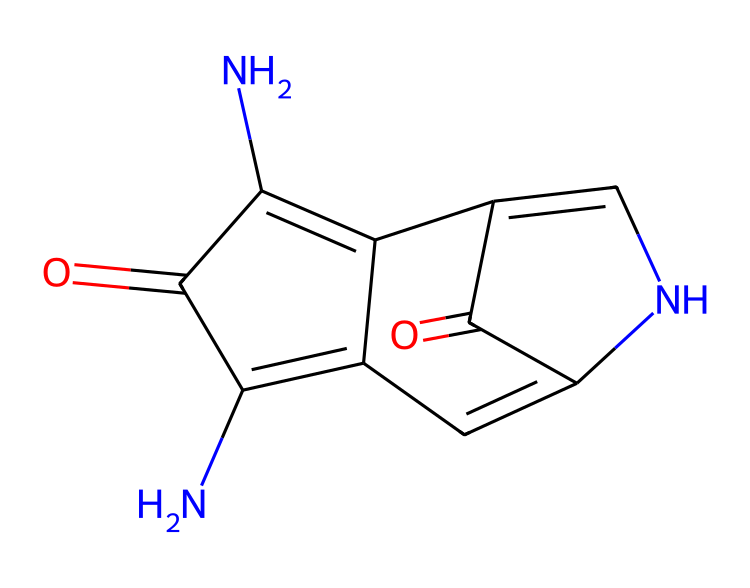What is the chemical name of this dye? The SMILES representation corresponds to indigo, a well-known dye used for coloring blue jeans. The structure includes characteristic features of indigo, including the fused ring system.
Answer: indigo How many nitrogen atoms are present in the chemical structure? Upon analyzing the SMILES, we can identify two nitrogen atoms present in the structure, which are indicated by the "N" symbols in the representation.
Answer: 2 What functional groups are present in indigo? The indigo structure contains carbonyl (C=O) groups as well as imine (C=N) functionalities, indicated by the presence of double bonds with oxygen and nitrogen atoms.
Answer: carbonyl, imine What is the total number of rings in the chemical structure? By examining the SMILES representation, we can see that there are three interconnected ring structures present in the indigo dye.
Answer: 3 What type of chemical compound is indigo? Indigo is characterized as a natural organic dye, which is confirmed by its structure and recognized use in dyeing processes, particularly in textiles.
Answer: organic dye Why does indigo exhibit a blue color? The blue color of indigo can be attributed to its conjugated system of double bonds, which allows for lower energy transitions and thus absorbs visible light in a specific spectrum resulting in a blue appearance.
Answer: conjugated system 